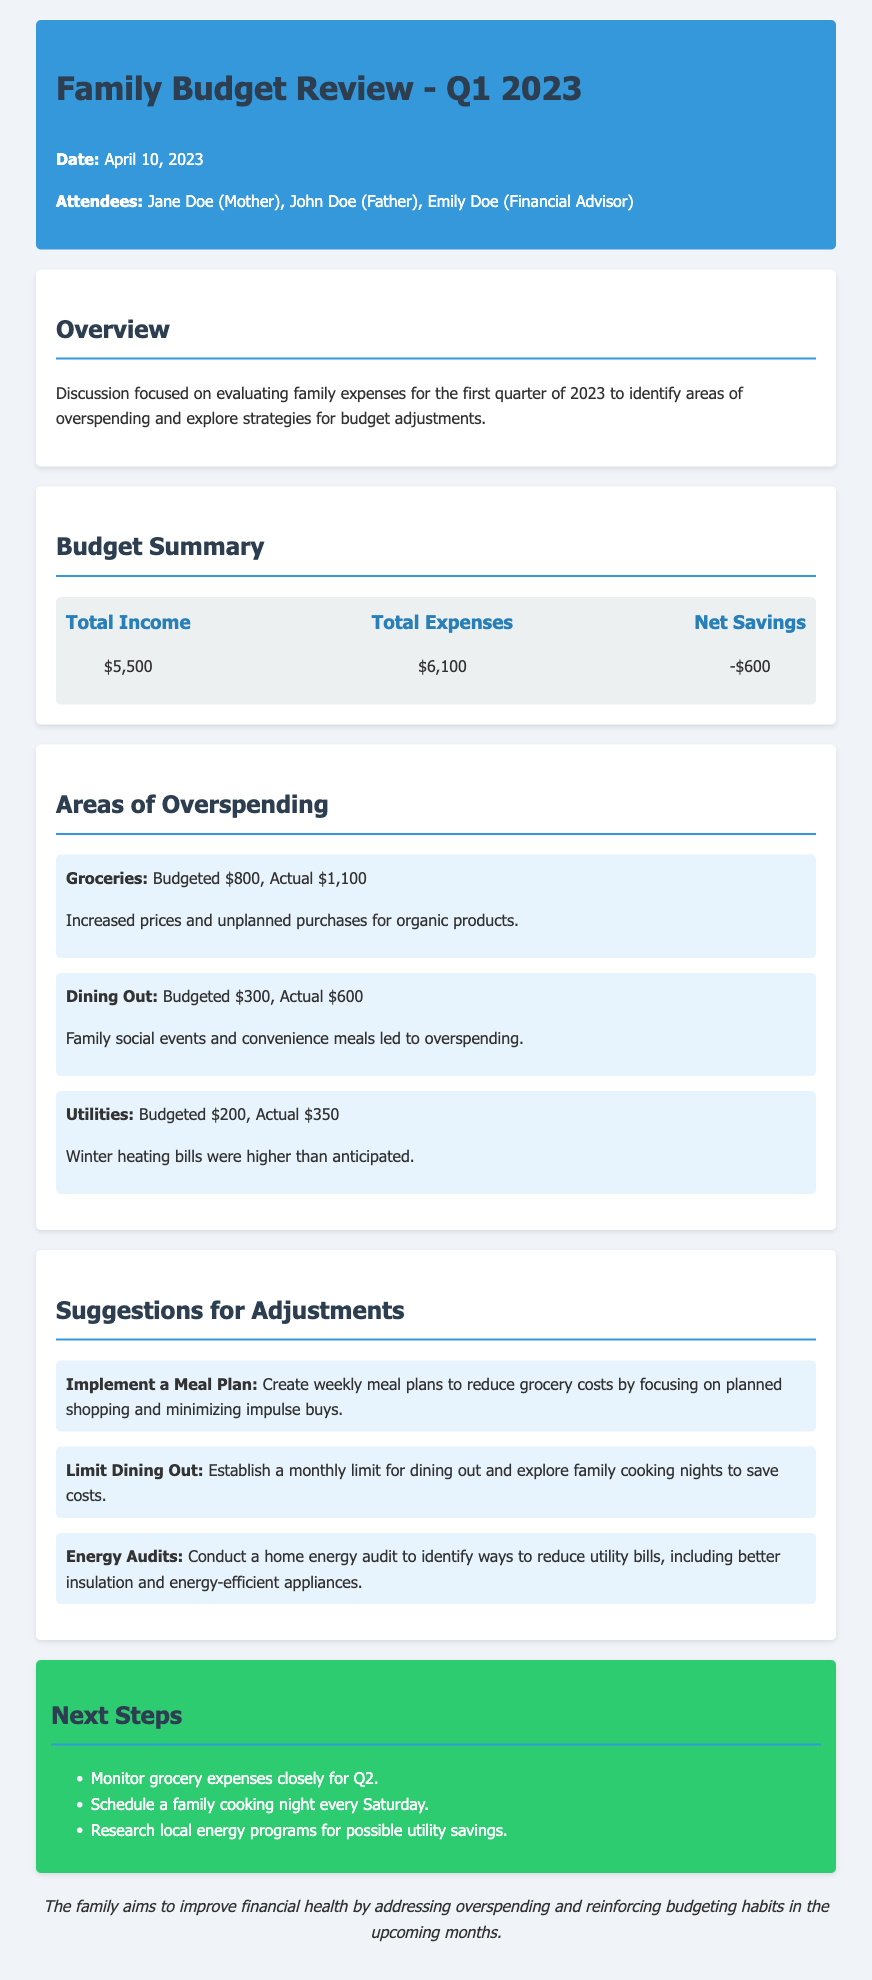What was the total income for Q1 2023? The total income is listed in the budget summary section of the document.
Answer: $5,500 What was the total expenses for Q1 2023? The total expenses can be found in the budget summary section of the document.
Answer: $6,100 What is the net savings for Q1 2023? The net savings is calculated as total income minus total expenses, found in the budget summary.
Answer: -$600 Which category had the highest overspending? The overspending category with the highest amount can be identified from the areas of overspending section.
Answer: Groceries What is the actual spending on dining out? The actual spending can be found in the areas of overspending section of the document.
Answer: $600 What suggestion was made to limit grocery costs? The suggestions section presents various adjustments for budget management.
Answer: Implement a Meal Plan How much was budgeted for utilities? The budgeted amount can be located in the areas of overspending section.
Answer: $200 When was the family budget review meeting held? The date of the meeting is stated near the top of the document.
Answer: April 10, 2023 What is a proposed action for the next steps regarding energy savings? The next steps section outlines specific actions planned for the upcoming quarter.
Answer: Research local energy programs for possible utility savings 